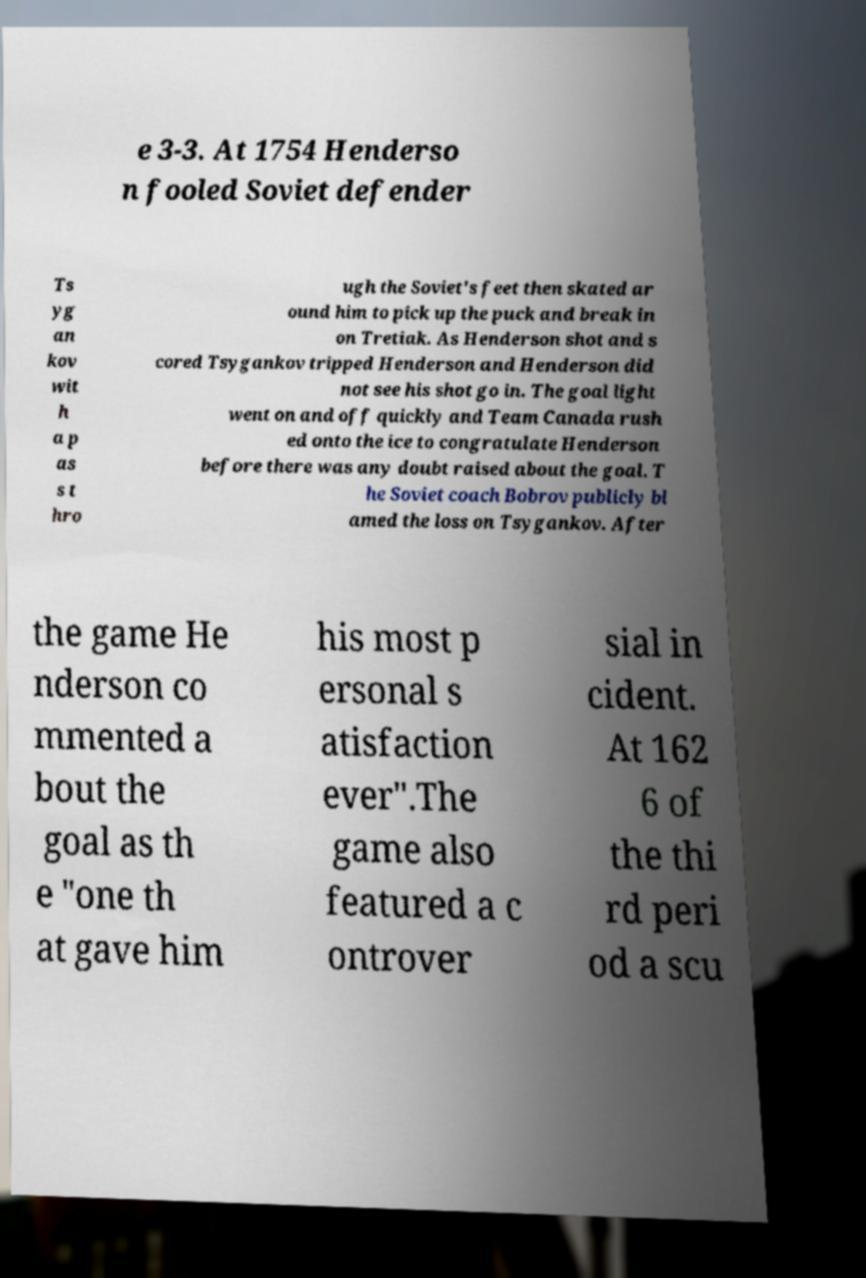I need the written content from this picture converted into text. Can you do that? e 3-3. At 1754 Henderso n fooled Soviet defender Ts yg an kov wit h a p as s t hro ugh the Soviet's feet then skated ar ound him to pick up the puck and break in on Tretiak. As Henderson shot and s cored Tsygankov tripped Henderson and Henderson did not see his shot go in. The goal light went on and off quickly and Team Canada rush ed onto the ice to congratulate Henderson before there was any doubt raised about the goal. T he Soviet coach Bobrov publicly bl amed the loss on Tsygankov. After the game He nderson co mmented a bout the goal as th e "one th at gave him his most p ersonal s atisfaction ever".The game also featured a c ontrover sial in cident. At 162 6 of the thi rd peri od a scu 